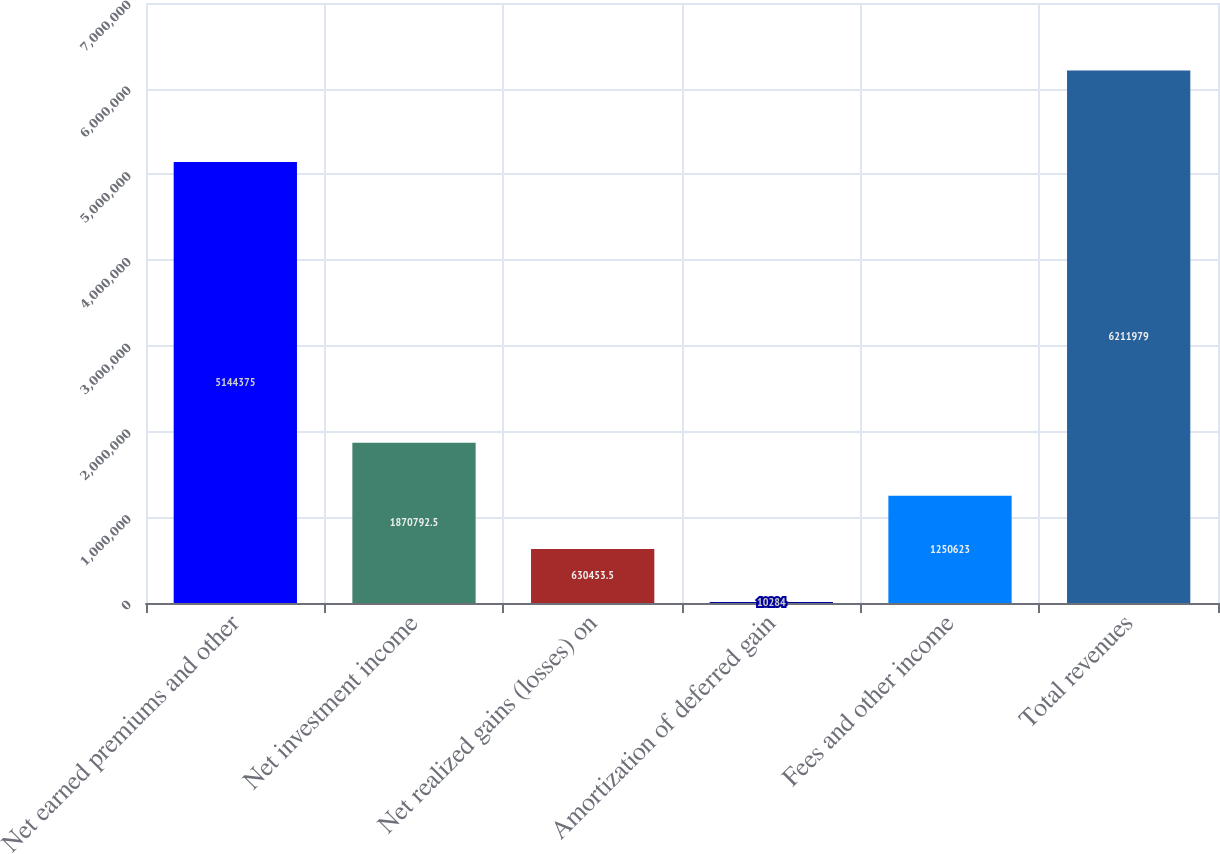<chart> <loc_0><loc_0><loc_500><loc_500><bar_chart><fcel>Net earned premiums and other<fcel>Net investment income<fcel>Net realized gains (losses) on<fcel>Amortization of deferred gain<fcel>Fees and other income<fcel>Total revenues<nl><fcel>5.14438e+06<fcel>1.87079e+06<fcel>630454<fcel>10284<fcel>1.25062e+06<fcel>6.21198e+06<nl></chart> 